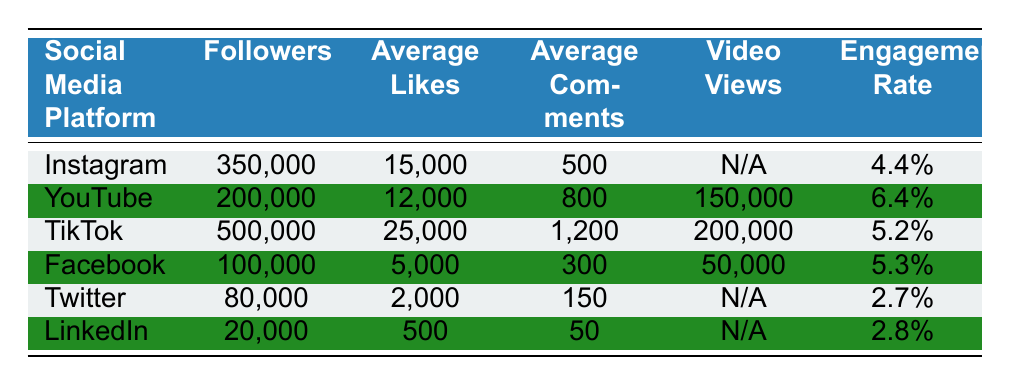What is the engagement rate for TikTok? The engagement rate for TikTok is directly listed in the table under the "Engagement Rate" column. It is 5.2%.
Answer: 5.2% Which social media platform has the highest number of average likes? To find the platform with the highest average likes, we compare the "Average Likes" values across all platforms. TikTok has the highest at 25,000 likes.
Answer: TikTok How many more followers does Instagram have than LinkedIn? We find the followers for Instagram (350,000) and LinkedIn (20,000). The difference is calculated as 350,000 - 20,000 = 330,000.
Answer: 330,000 Is the average number of comments on YouTube greater than on Facebook? Checking the "Average Comments" column, YouTube has 800 comments while Facebook has 300 comments. Since 800 > 300, the statement is true.
Answer: Yes What is the total number of followers across all platforms? We sum the followers from each platform: 350,000 (Instagram) + 200,000 (YouTube) + 500,000 (TikTok) + 100,000 (Facebook) + 80,000 (Twitter) + 20,000 (LinkedIn) = 1,350,000.
Answer: 1,350,000 Which platform has a higher engagement rate, Instagram or Facebook? Comparing the engagement rates from the table, Instagram has 4.4% while Facebook has 5.3%. Since 5.3% > 4.4%, Facebook has a higher rate.
Answer: Facebook What is the average engagement rate of all platforms listed? We calculate the engagement rates: (4.4% + 6.4% + 5.2% + 5.3% + 2.7% + 2.8%) / 6 = 4.3%.
Answer: 4.3% Does TikTok have more video views than YouTube? The video views for TikTok (200,000) and YouTube (150,000) can be compared. Since 200,000 > 150,000, the statement is true.
Answer: Yes What is the ratio of average likes on TikTok to average likes on Twitter? We take the average likes for TikTok (25,000) and Twitter (2,000). The ratio is 25,000 / 2,000 = 12.5.
Answer: 12.5 Which social media platform has the lowest average comments? By looking at the "Average Comments" column, we find that LinkedIn has the lowest value with 50 comments.
Answer: LinkedIn 